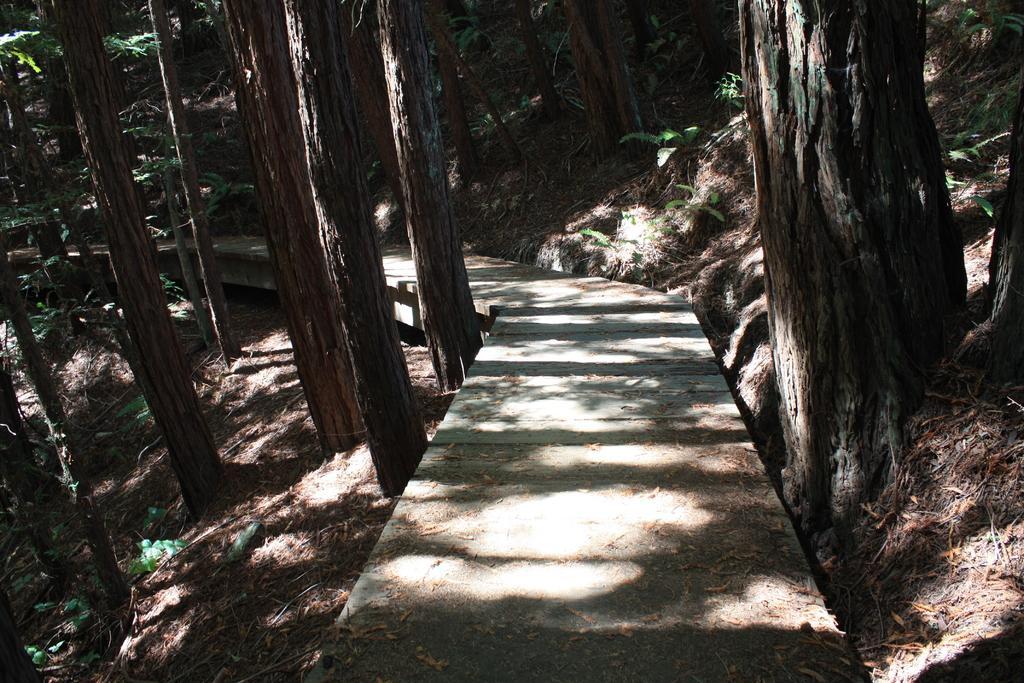In one or two sentences, can you explain what this image depicts? In the image we can see there is a footpath in the middle and on both the sides there are lot of trees. There are dry leaves on the ground. 